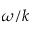Convert formula to latex. <formula><loc_0><loc_0><loc_500><loc_500>\omega / k</formula> 